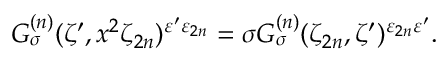Convert formula to latex. <formula><loc_0><loc_0><loc_500><loc_500>G _ { \sigma } ^ { ( n ) } ( \zeta ^ { \prime } , x ^ { 2 } \zeta _ { 2 n } ) ^ { \varepsilon ^ { \prime } \varepsilon _ { 2 n } } = \sigma G _ { \sigma } ^ { ( n ) } ( \zeta _ { 2 n } , \zeta ^ { \prime } ) ^ { \varepsilon _ { 2 n } \varepsilon ^ { \prime } } .</formula> 